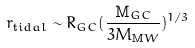Convert formula to latex. <formula><loc_0><loc_0><loc_500><loc_500>r _ { \mathrm t i d a l } \sim R _ { G C } ( \frac { \mathrm M _ { G C } } { 3 M _ { \mathrm M W } } ) ^ { 1 / 3 }</formula> 